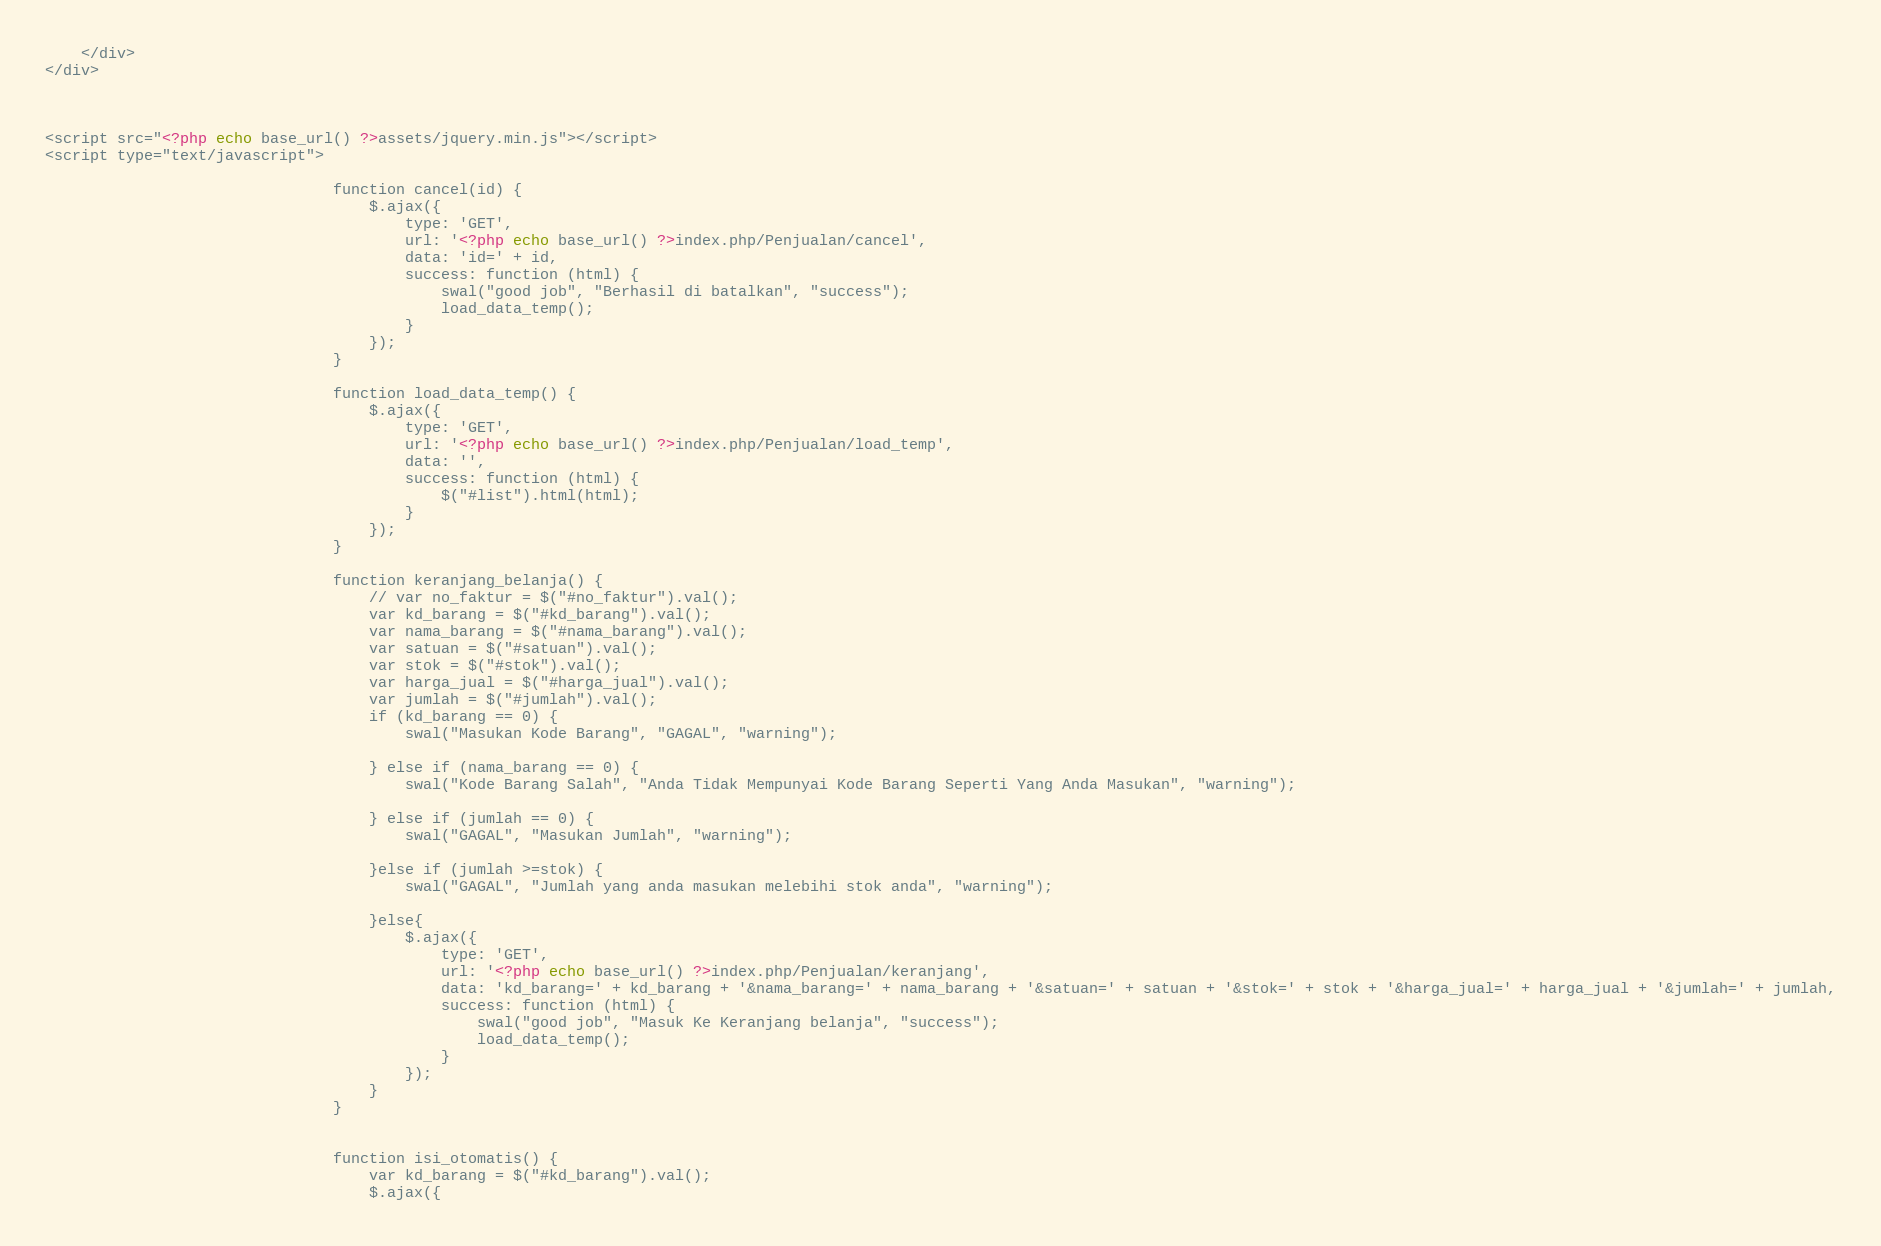<code> <loc_0><loc_0><loc_500><loc_500><_PHP_>
    </div>
</div>



<script src="<?php echo base_url() ?>assets/jquery.min.js"></script>
<script type="text/javascript">
    
                                function cancel(id) {
                                    $.ajax({
                                        type: 'GET',
                                        url: '<?php echo base_url() ?>index.php/Penjualan/cancel',
                                        data: 'id=' + id,
                                        success: function (html) {
                                            swal("good job", "Berhasil di batalkan", "success");
                                            load_data_temp();
                                        }
                                    });
                                }

                                function load_data_temp() {
                                    $.ajax({
                                        type: 'GET',
                                        url: '<?php echo base_url() ?>index.php/Penjualan/load_temp',
                                        data: '',
                                        success: function (html) {
                                            $("#list").html(html);
                                        }
                                    });
                                }

                                function keranjang_belanja() {
                                    // var no_faktur = $("#no_faktur").val();
                                    var kd_barang = $("#kd_barang").val();
                                    var nama_barang = $("#nama_barang").val();
                                    var satuan = $("#satuan").val();
                                    var stok = $("#stok").val();
                                    var harga_jual = $("#harga_jual").val();
                                    var jumlah = $("#jumlah").val();
                                    if (kd_barang == 0) {
                                        swal("Masukan Kode Barang", "GAGAL", "warning");

                                    } else if (nama_barang == 0) {
                                        swal("Kode Barang Salah", "Anda Tidak Mempunyai Kode Barang Seperti Yang Anda Masukan", "warning");

                                    } else if (jumlah == 0) {
                                        swal("GAGAL", "Masukan Jumlah", "warning");

                                    }else if (jumlah >=stok) {
                                        swal("GAGAL", "Jumlah yang anda masukan melebihi stok anda", "warning");

                                    }else{
                                        $.ajax({
                                            type: 'GET',
                                            url: '<?php echo base_url() ?>index.php/Penjualan/keranjang',
                                            data: 'kd_barang=' + kd_barang + '&nama_barang=' + nama_barang + '&satuan=' + satuan + '&stok=' + stok + '&harga_jual=' + harga_jual + '&jumlah=' + jumlah,
                                            success: function (html) {
                                                swal("good job", "Masuk Ke Keranjang belanja", "success");
                                                load_data_temp();
                                            }
                                        });
                                    }
                                }


                                function isi_otomatis() {
                                    var kd_barang = $("#kd_barang").val();
                                    $.ajax({</code> 